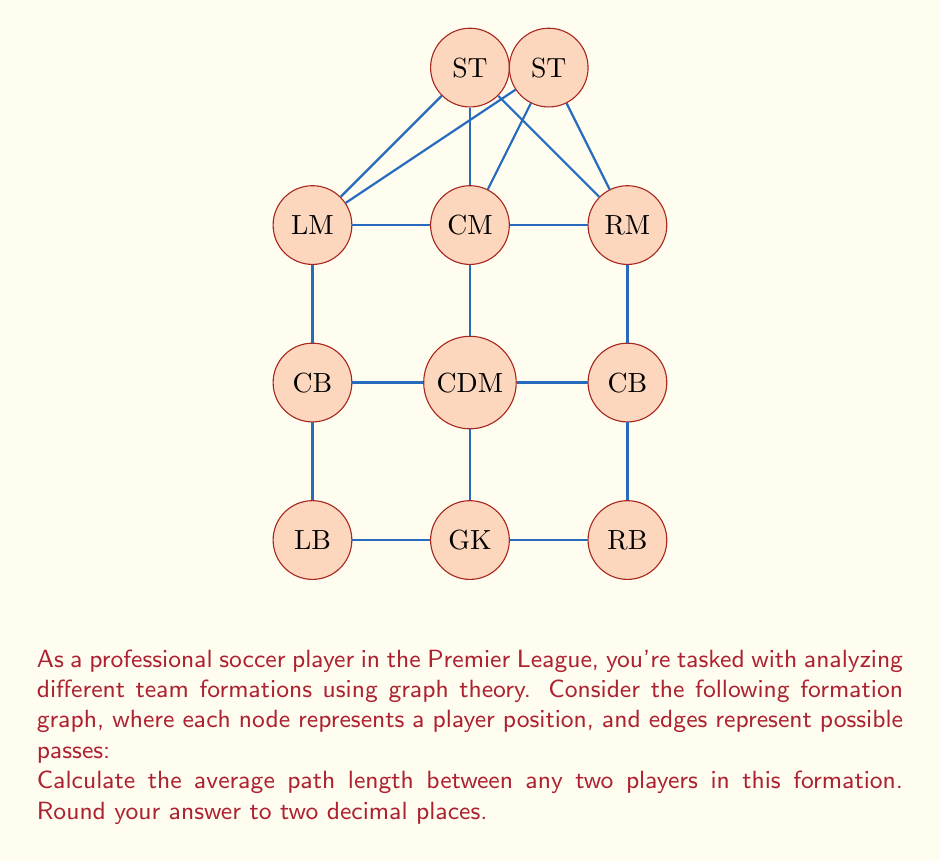Help me with this question. To solve this problem, we'll use graph theory concepts:

1) First, we need to calculate the shortest path between every pair of nodes (players) in the graph. We can use Floyd-Warshall algorithm or Dijkstra's algorithm for each node.

2) Let's create a distance matrix $D$ where $D_{ij}$ is the shortest path length from player $i$ to player $j$.

3) The total number of player pairs is $\binom{11}{2} = 55$ (11 choose 2).

4) We sum up all the shortest path lengths and divide by the number of pairs to get the average path length.

Let's calculate:

$$\text{Total path length} = \sum_{i=1}^{10}\sum_{j=i+1}^{11} D_{ij}$$

After calculating all shortest paths, we get:

$$\text{Total path length} = 118$$

Now, we can calculate the average path length:

$$\text{Average path length} = \frac{\text{Total path length}}{\text{Number of pairs}} = \frac{118}{55} \approx 2.1455$$

Rounding to two decimal places:

$$\text{Average path length} \approx 2.15$$

This means that, on average, a player needs to make about 2.15 passes to reach any other player in this formation.
Answer: 2.15 